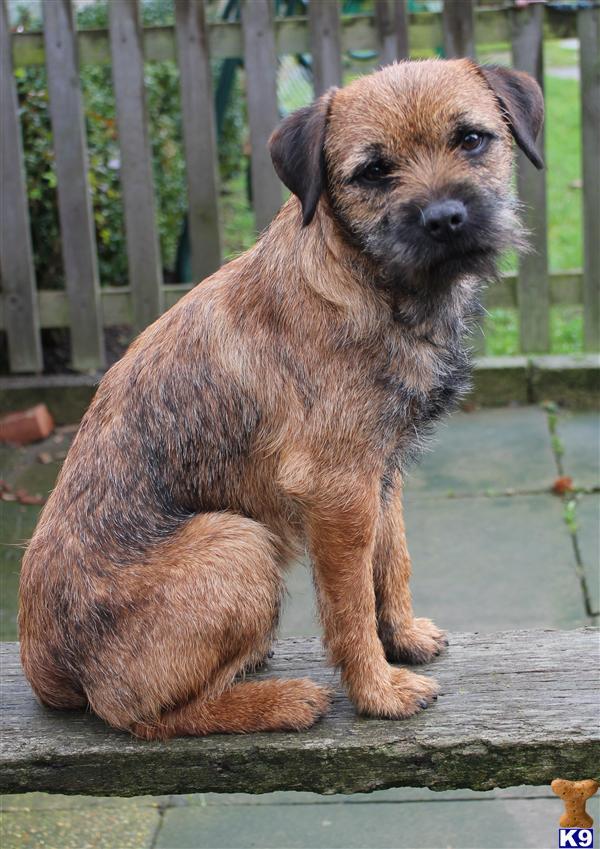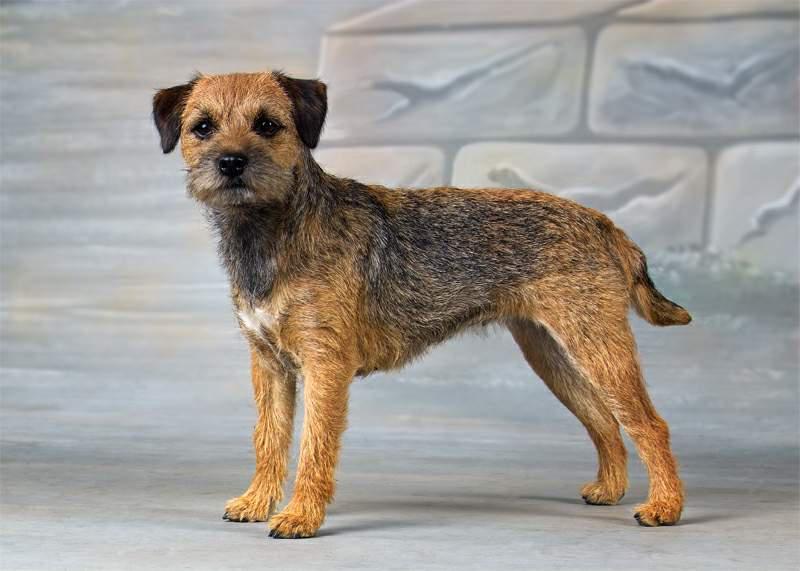The first image is the image on the left, the second image is the image on the right. Evaluate the accuracy of this statement regarding the images: "There are at least two animals in the image on the right.". Is it true? Answer yes or no. No. The first image is the image on the left, the second image is the image on the right. Examine the images to the left and right. Is the description "Dog are shown with a dead animal in at least one of the images." accurate? Answer yes or no. No. 